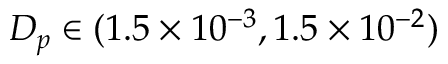<formula> <loc_0><loc_0><loc_500><loc_500>{ D _ { p } } \in ( 1 . 5 \times { 1 0 ^ { - 3 } } , 1 . 5 \times { 1 0 ^ { - 2 } } )</formula> 